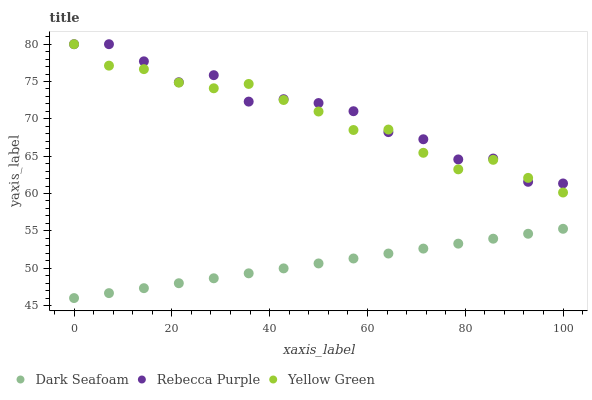Does Dark Seafoam have the minimum area under the curve?
Answer yes or no. Yes. Does Rebecca Purple have the maximum area under the curve?
Answer yes or no. Yes. Does Yellow Green have the minimum area under the curve?
Answer yes or no. No. Does Yellow Green have the maximum area under the curve?
Answer yes or no. No. Is Dark Seafoam the smoothest?
Answer yes or no. Yes. Is Rebecca Purple the roughest?
Answer yes or no. Yes. Is Yellow Green the smoothest?
Answer yes or no. No. Is Yellow Green the roughest?
Answer yes or no. No. Does Dark Seafoam have the lowest value?
Answer yes or no. Yes. Does Yellow Green have the lowest value?
Answer yes or no. No. Does Yellow Green have the highest value?
Answer yes or no. Yes. Is Dark Seafoam less than Yellow Green?
Answer yes or no. Yes. Is Rebecca Purple greater than Dark Seafoam?
Answer yes or no. Yes. Does Yellow Green intersect Rebecca Purple?
Answer yes or no. Yes. Is Yellow Green less than Rebecca Purple?
Answer yes or no. No. Is Yellow Green greater than Rebecca Purple?
Answer yes or no. No. Does Dark Seafoam intersect Yellow Green?
Answer yes or no. No. 